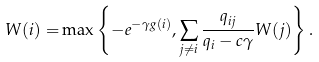Convert formula to latex. <formula><loc_0><loc_0><loc_500><loc_500>W ( i ) = & \max \left \{ - e ^ { - \gamma g ( i ) } , \sum _ { j \neq i } \frac { q _ { i j } } { q _ { i } - c \gamma } W ( j ) \right \} .</formula> 